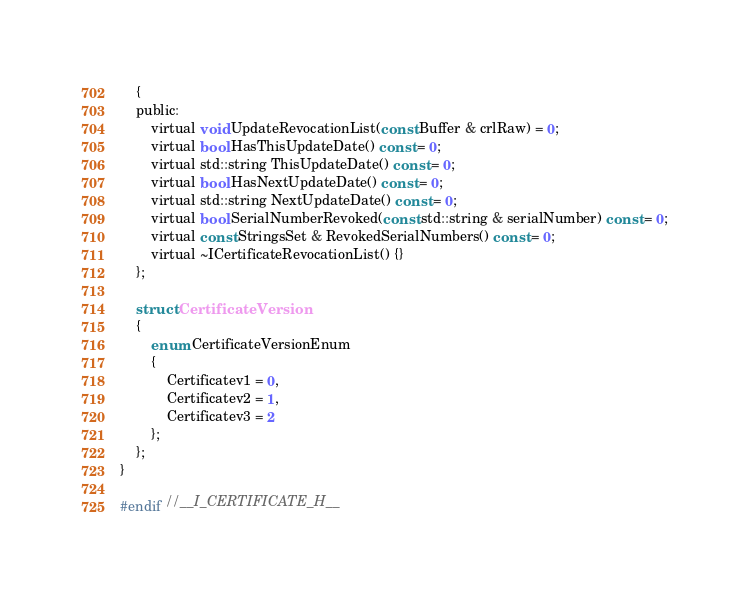<code> <loc_0><loc_0><loc_500><loc_500><_C_>    {
    public:
        virtual void UpdateRevocationList(const Buffer & crlRaw) = 0;
        virtual bool HasThisUpdateDate() const = 0;
        virtual std::string ThisUpdateDate() const = 0;
        virtual bool HasNextUpdateDate() const = 0;
        virtual std::string NextUpdateDate() const = 0;
        virtual bool SerialNumberRevoked(const std::string & serialNumber) const = 0;
        virtual const StringsSet & RevokedSerialNumbers() const = 0;
        virtual ~ICertificateRevocationList() {}
    };

    struct CertificateVersion
    {
        enum CertificateVersionEnum
        {
            Certificatev1 = 0,
            Certificatev2 = 1,
            Certificatev3 = 2
        };
    };
}

#endif //__I_CERTIFICATE_H__
</code> 